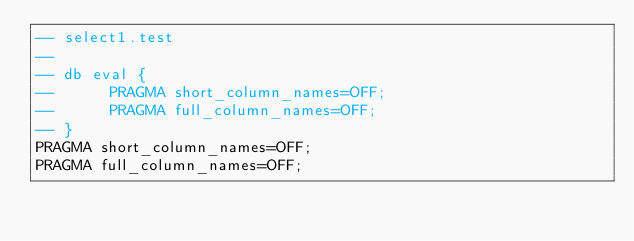<code> <loc_0><loc_0><loc_500><loc_500><_SQL_>-- select1.test
-- 
-- db eval {
--      PRAGMA short_column_names=OFF;
--      PRAGMA full_column_names=OFF;
-- }
PRAGMA short_column_names=OFF;
PRAGMA full_column_names=OFF;</code> 